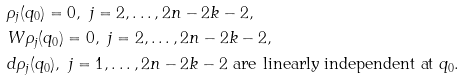<formula> <loc_0><loc_0><loc_500><loc_500>& \rho _ { j } ( q _ { 0 } ) = 0 , \ j = 2 , \dots , 2 n - 2 k - 2 , \\ & W \rho _ { j } ( q _ { 0 } ) = 0 , \ j = 2 , \dots , 2 n - 2 k - 2 , \\ & d \rho _ { j } ( q _ { 0 } ) , \ j = 1 , \dots , 2 n - 2 k - 2 \ \text {are linearly independent at} \ q _ { 0 } . \\</formula> 